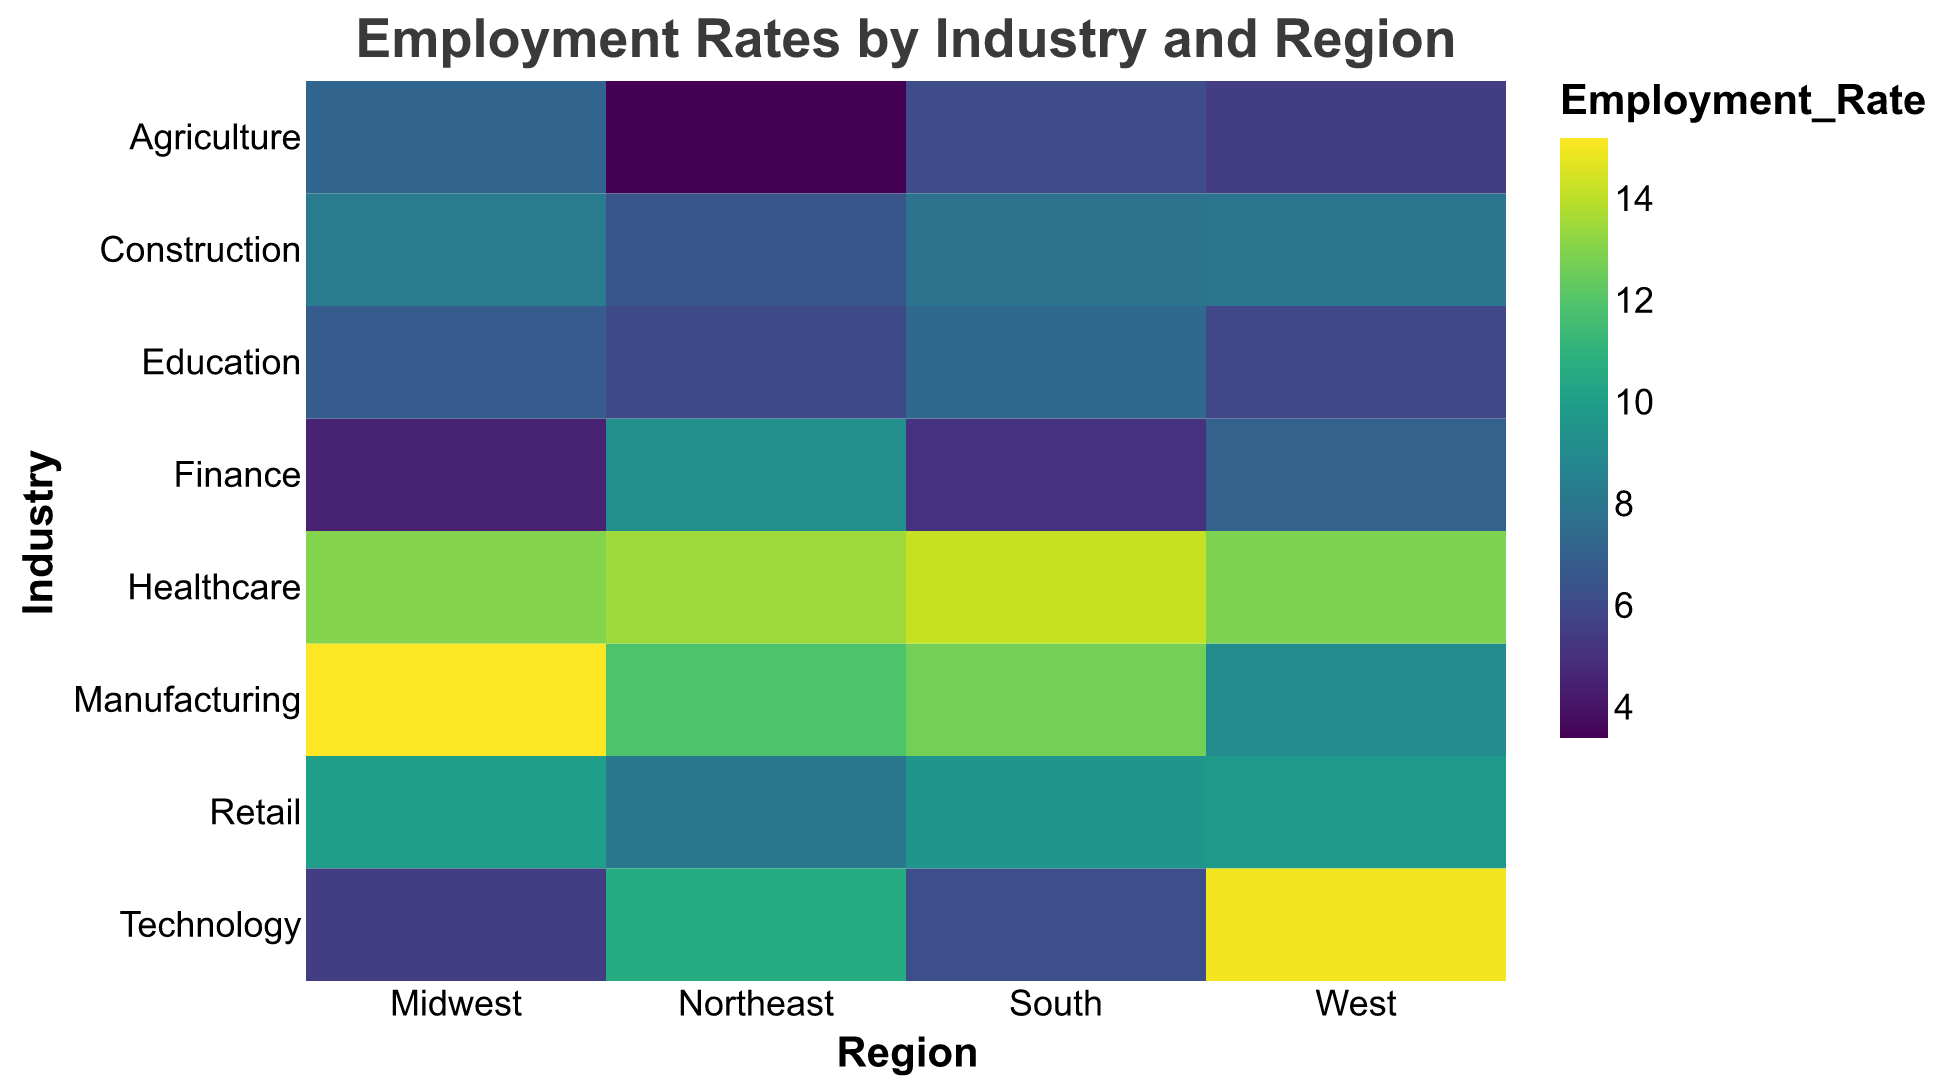What is the title of the heatmap? The title is displayed at the top of the heatmap and reads "Employment Rates by Industry and Region".
Answer: Employment Rates by Industry and Region Which industry has the highest employment rate in the West? By looking at the color intensity and corresponding employment rate in the West region, Technology has the highest rate.
Answer: Technology How do the employment rates in Agriculture compare between the Midwest and Northeast? The Midwest has an employment rate of 7.2, while the Northeast has a rate of 3.4. Comparing these, the Midwest has a higher employment rate in Agriculture.
Answer: Midwest is higher What is the average employment rate for Construction across all regions? Sum the employment rates for Construction (8.3 + 7.9 + 6.5 + 8.0 = 30.7) and then divide by the number of regions (4): 30.7 / 4 = 7.675.
Answer: 7.675 Which region has the lowest employment rate in Finance? Comparing the employment rates for Finance, the Midwest has the lowest at 4.5.
Answer: Midwest In which region does Healthcare have the most balanced employment rate compared to other industries? By examining the color distribution, Healthcare employment is relatively balanced (comparable intensities) across all regions compared to the variability in other industries.
Answer: All regions are balanced Compare the employment rate in Manufacturing between the Midwest and South. What is the difference? The Midwest has an employment rate of 15.2, while the South has 12.7. Subtracting these, the difference is 15.2 - 12.7 = 2.5.
Answer: 2.5 Which industry shows the least regional variation in employment rates? Looking at the heatmap, Education shows relatively consistent employment rates (similar color intensities) across all regions.
Answer: Education Is there any industry that has higher employment rates in the Northeast compared to other regions? Looking at the heatmap, Technology has a higher employment rate in the Northeast (10.7) compared to the Midwest (5.5) and the South (6.2).
Answer: Technology Which region has the most variability in employment rates across different industries? Examining the color intensities for each region, the West shows the most variability, with rates ranging from 5.5 in Agriculture to 15.0 in Technology.
Answer: West 